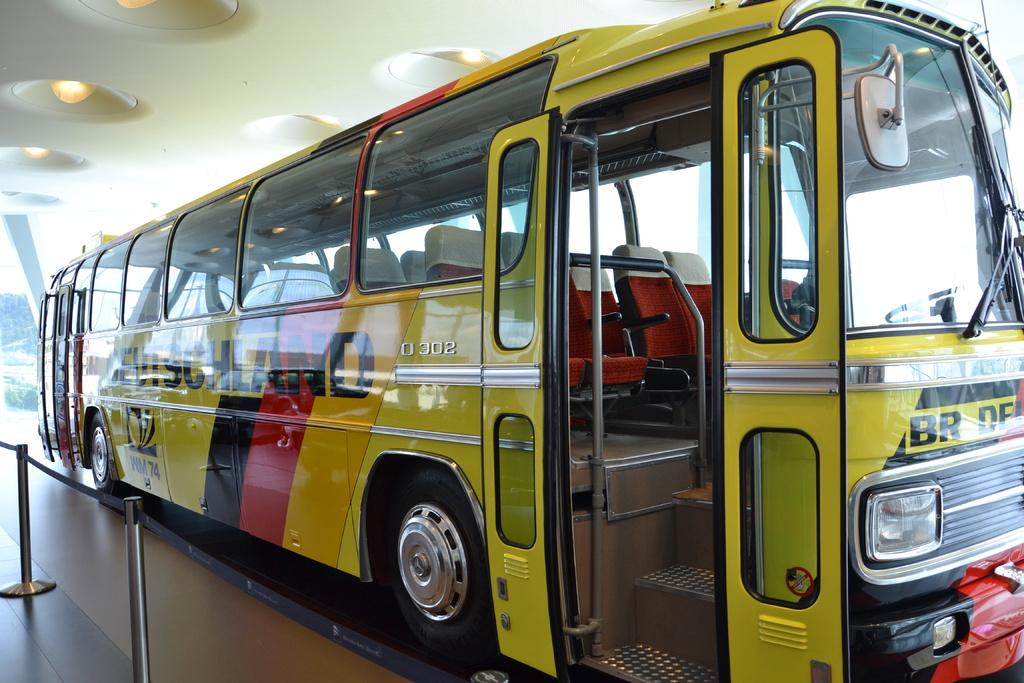What is the main subject of the image? There is a bus in the image. What color is the bus? The bus is yellow in color. What can be seen at the top of the image? There are lights at the top of the image. What is present at the bottom of the image? There are poles at the bottom of the image. What surface is visible in the image? There is a floor visible in the image. What type of recess can be seen in the design of the bus? There is no recess present in the design of the bus; it is a solid yellow color. What alarm is going off in the image? There is no alarm going off in the image; it only features a bus, lights, poles, and a floor. 